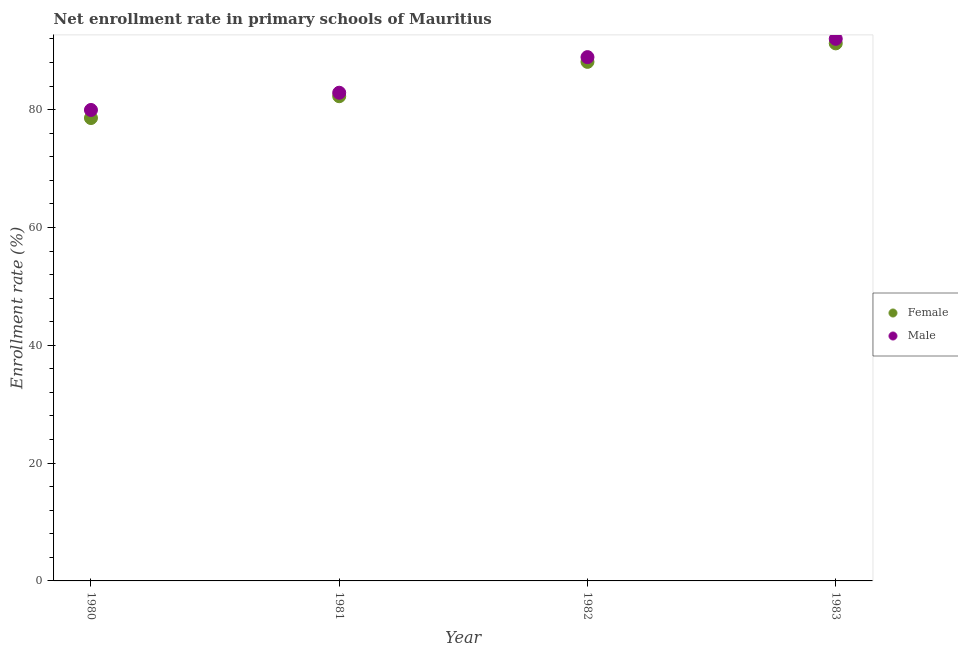Is the number of dotlines equal to the number of legend labels?
Give a very brief answer. Yes. What is the enrollment rate of male students in 1983?
Give a very brief answer. 92.02. Across all years, what is the maximum enrollment rate of male students?
Ensure brevity in your answer.  92.02. Across all years, what is the minimum enrollment rate of female students?
Ensure brevity in your answer.  78.57. In which year was the enrollment rate of female students maximum?
Your response must be concise. 1983. What is the total enrollment rate of male students in the graph?
Ensure brevity in your answer.  343.74. What is the difference between the enrollment rate of female students in 1981 and that in 1982?
Offer a very short reply. -5.83. What is the difference between the enrollment rate of female students in 1981 and the enrollment rate of male students in 1983?
Make the answer very short. -9.74. What is the average enrollment rate of male students per year?
Offer a terse response. 85.93. In the year 1983, what is the difference between the enrollment rate of male students and enrollment rate of female students?
Your answer should be compact. 0.77. What is the ratio of the enrollment rate of female students in 1980 to that in 1983?
Your answer should be compact. 0.86. Is the enrollment rate of female students in 1982 less than that in 1983?
Offer a very short reply. Yes. Is the difference between the enrollment rate of female students in 1980 and 1981 greater than the difference between the enrollment rate of male students in 1980 and 1981?
Your answer should be compact. No. What is the difference between the highest and the second highest enrollment rate of female students?
Offer a terse response. 3.14. What is the difference between the highest and the lowest enrollment rate of female students?
Keep it short and to the point. 12.67. Is the sum of the enrollment rate of female students in 1981 and 1982 greater than the maximum enrollment rate of male students across all years?
Provide a short and direct response. Yes. How many years are there in the graph?
Make the answer very short. 4. What is the difference between two consecutive major ticks on the Y-axis?
Provide a short and direct response. 20. Does the graph contain any zero values?
Provide a short and direct response. No. Does the graph contain grids?
Ensure brevity in your answer.  No. What is the title of the graph?
Keep it short and to the point. Net enrollment rate in primary schools of Mauritius. What is the label or title of the X-axis?
Offer a terse response. Year. What is the label or title of the Y-axis?
Make the answer very short. Enrollment rate (%). What is the Enrollment rate (%) of Female in 1980?
Your answer should be very brief. 78.57. What is the Enrollment rate (%) in Male in 1980?
Ensure brevity in your answer.  79.94. What is the Enrollment rate (%) in Female in 1981?
Your answer should be compact. 82.28. What is the Enrollment rate (%) in Male in 1981?
Your response must be concise. 82.87. What is the Enrollment rate (%) in Female in 1982?
Keep it short and to the point. 88.11. What is the Enrollment rate (%) in Male in 1982?
Your answer should be very brief. 88.91. What is the Enrollment rate (%) in Female in 1983?
Your response must be concise. 91.24. What is the Enrollment rate (%) of Male in 1983?
Keep it short and to the point. 92.02. Across all years, what is the maximum Enrollment rate (%) of Female?
Your response must be concise. 91.24. Across all years, what is the maximum Enrollment rate (%) of Male?
Your answer should be very brief. 92.02. Across all years, what is the minimum Enrollment rate (%) of Female?
Provide a succinct answer. 78.57. Across all years, what is the minimum Enrollment rate (%) in Male?
Ensure brevity in your answer.  79.94. What is the total Enrollment rate (%) in Female in the graph?
Your answer should be very brief. 340.2. What is the total Enrollment rate (%) in Male in the graph?
Your response must be concise. 343.74. What is the difference between the Enrollment rate (%) of Female in 1980 and that in 1981?
Offer a terse response. -3.7. What is the difference between the Enrollment rate (%) of Male in 1980 and that in 1981?
Your response must be concise. -2.93. What is the difference between the Enrollment rate (%) in Female in 1980 and that in 1982?
Provide a short and direct response. -9.53. What is the difference between the Enrollment rate (%) in Male in 1980 and that in 1982?
Your answer should be compact. -8.97. What is the difference between the Enrollment rate (%) in Female in 1980 and that in 1983?
Give a very brief answer. -12.67. What is the difference between the Enrollment rate (%) in Male in 1980 and that in 1983?
Provide a succinct answer. -12.07. What is the difference between the Enrollment rate (%) in Female in 1981 and that in 1982?
Make the answer very short. -5.83. What is the difference between the Enrollment rate (%) in Male in 1981 and that in 1982?
Offer a terse response. -6.04. What is the difference between the Enrollment rate (%) in Female in 1981 and that in 1983?
Give a very brief answer. -8.97. What is the difference between the Enrollment rate (%) of Male in 1981 and that in 1983?
Provide a succinct answer. -9.15. What is the difference between the Enrollment rate (%) of Female in 1982 and that in 1983?
Ensure brevity in your answer.  -3.14. What is the difference between the Enrollment rate (%) in Male in 1982 and that in 1983?
Offer a terse response. -3.11. What is the difference between the Enrollment rate (%) in Female in 1980 and the Enrollment rate (%) in Male in 1981?
Offer a very short reply. -4.3. What is the difference between the Enrollment rate (%) of Female in 1980 and the Enrollment rate (%) of Male in 1982?
Ensure brevity in your answer.  -10.34. What is the difference between the Enrollment rate (%) of Female in 1980 and the Enrollment rate (%) of Male in 1983?
Your response must be concise. -13.44. What is the difference between the Enrollment rate (%) in Female in 1981 and the Enrollment rate (%) in Male in 1982?
Your response must be concise. -6.63. What is the difference between the Enrollment rate (%) of Female in 1981 and the Enrollment rate (%) of Male in 1983?
Offer a terse response. -9.74. What is the difference between the Enrollment rate (%) of Female in 1982 and the Enrollment rate (%) of Male in 1983?
Your response must be concise. -3.91. What is the average Enrollment rate (%) in Female per year?
Keep it short and to the point. 85.05. What is the average Enrollment rate (%) in Male per year?
Your response must be concise. 85.93. In the year 1980, what is the difference between the Enrollment rate (%) in Female and Enrollment rate (%) in Male?
Make the answer very short. -1.37. In the year 1981, what is the difference between the Enrollment rate (%) in Female and Enrollment rate (%) in Male?
Provide a short and direct response. -0.59. In the year 1982, what is the difference between the Enrollment rate (%) in Female and Enrollment rate (%) in Male?
Keep it short and to the point. -0.8. In the year 1983, what is the difference between the Enrollment rate (%) of Female and Enrollment rate (%) of Male?
Provide a short and direct response. -0.77. What is the ratio of the Enrollment rate (%) of Female in 1980 to that in 1981?
Your answer should be very brief. 0.95. What is the ratio of the Enrollment rate (%) in Male in 1980 to that in 1981?
Provide a succinct answer. 0.96. What is the ratio of the Enrollment rate (%) in Female in 1980 to that in 1982?
Ensure brevity in your answer.  0.89. What is the ratio of the Enrollment rate (%) in Male in 1980 to that in 1982?
Your answer should be very brief. 0.9. What is the ratio of the Enrollment rate (%) of Female in 1980 to that in 1983?
Offer a very short reply. 0.86. What is the ratio of the Enrollment rate (%) in Male in 1980 to that in 1983?
Provide a succinct answer. 0.87. What is the ratio of the Enrollment rate (%) of Female in 1981 to that in 1982?
Your response must be concise. 0.93. What is the ratio of the Enrollment rate (%) in Male in 1981 to that in 1982?
Offer a terse response. 0.93. What is the ratio of the Enrollment rate (%) of Female in 1981 to that in 1983?
Keep it short and to the point. 0.9. What is the ratio of the Enrollment rate (%) of Male in 1981 to that in 1983?
Your answer should be very brief. 0.9. What is the ratio of the Enrollment rate (%) of Female in 1982 to that in 1983?
Provide a succinct answer. 0.97. What is the ratio of the Enrollment rate (%) of Male in 1982 to that in 1983?
Make the answer very short. 0.97. What is the difference between the highest and the second highest Enrollment rate (%) in Female?
Give a very brief answer. 3.14. What is the difference between the highest and the second highest Enrollment rate (%) in Male?
Provide a short and direct response. 3.11. What is the difference between the highest and the lowest Enrollment rate (%) in Female?
Make the answer very short. 12.67. What is the difference between the highest and the lowest Enrollment rate (%) of Male?
Make the answer very short. 12.07. 